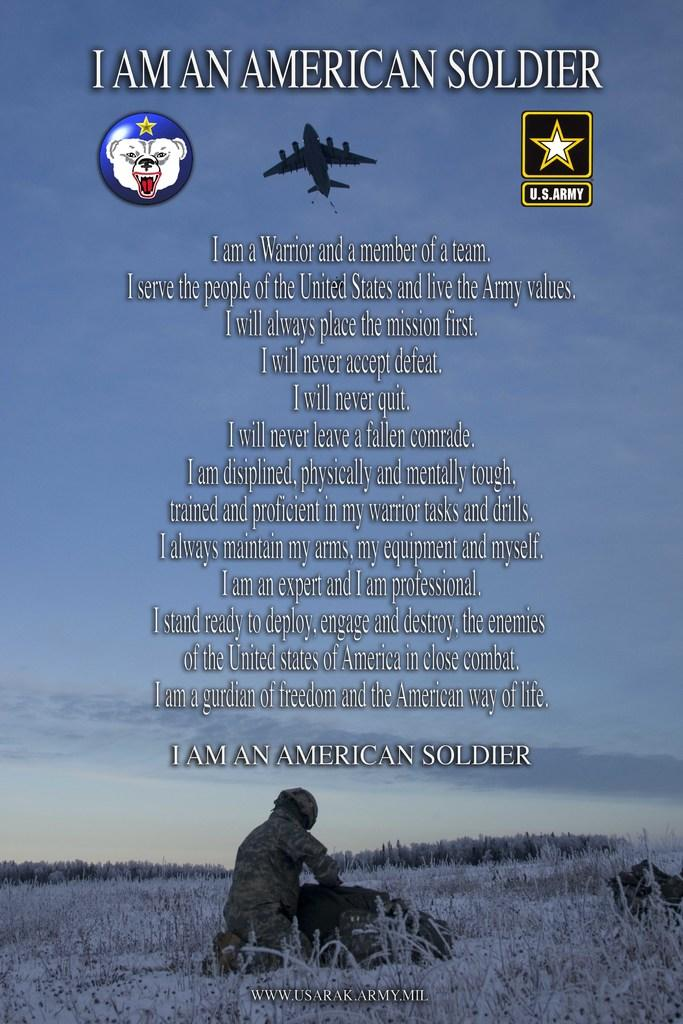<image>
Share a concise interpretation of the image provided. american propaganda poster that says i am an american soldier on the top. 